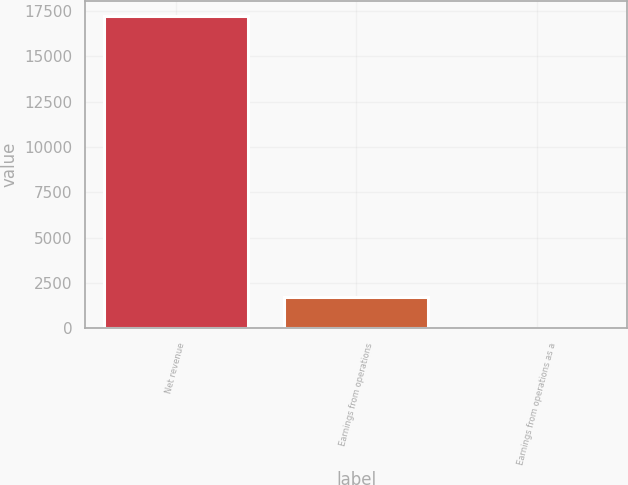Convert chart. <chart><loc_0><loc_0><loc_500><loc_500><bar_chart><fcel>Net revenue<fcel>Earnings from operations<fcel>Earnings from operations as a<nl><fcel>17211<fcel>1729.2<fcel>9<nl></chart> 